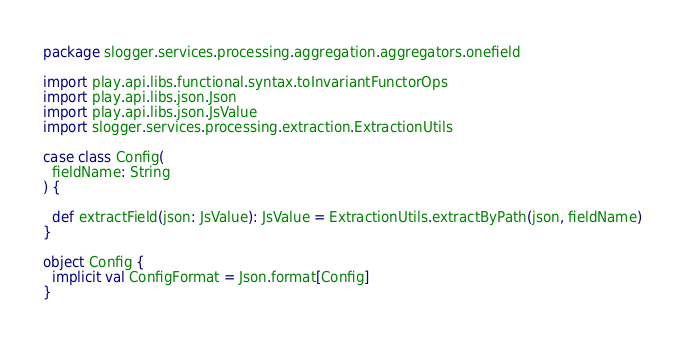<code> <loc_0><loc_0><loc_500><loc_500><_Scala_>package slogger.services.processing.aggregation.aggregators.onefield

import play.api.libs.functional.syntax.toInvariantFunctorOps
import play.api.libs.json.Json
import play.api.libs.json.JsValue
import slogger.services.processing.extraction.ExtractionUtils

case class Config(
  fieldName: String    
) {
  
  def extractField(json: JsValue): JsValue = ExtractionUtils.extractByPath(json, fieldName)
}

object Config {
  implicit val ConfigFormat = Json.format[Config]
}</code> 